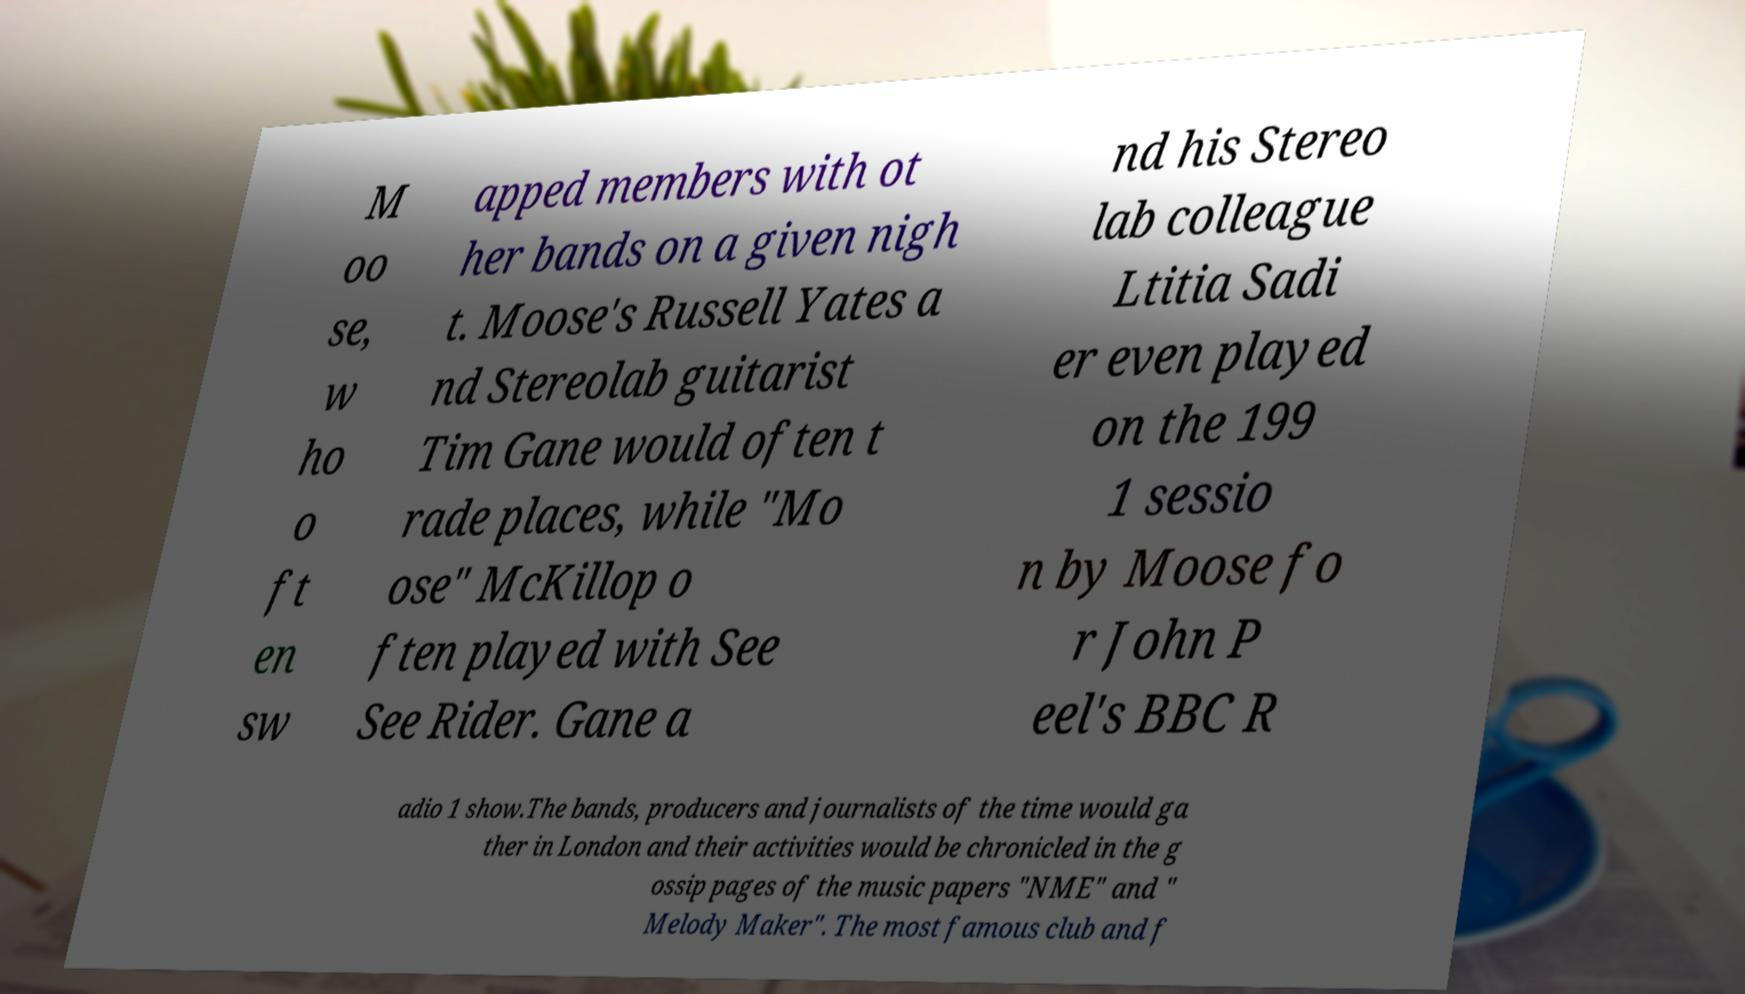Please read and relay the text visible in this image. What does it say? M oo se, w ho o ft en sw apped members with ot her bands on a given nigh t. Moose's Russell Yates a nd Stereolab guitarist Tim Gane would often t rade places, while "Mo ose" McKillop o ften played with See See Rider. Gane a nd his Stereo lab colleague Ltitia Sadi er even played on the 199 1 sessio n by Moose fo r John P eel's BBC R adio 1 show.The bands, producers and journalists of the time would ga ther in London and their activities would be chronicled in the g ossip pages of the music papers "NME" and " Melody Maker". The most famous club and f 